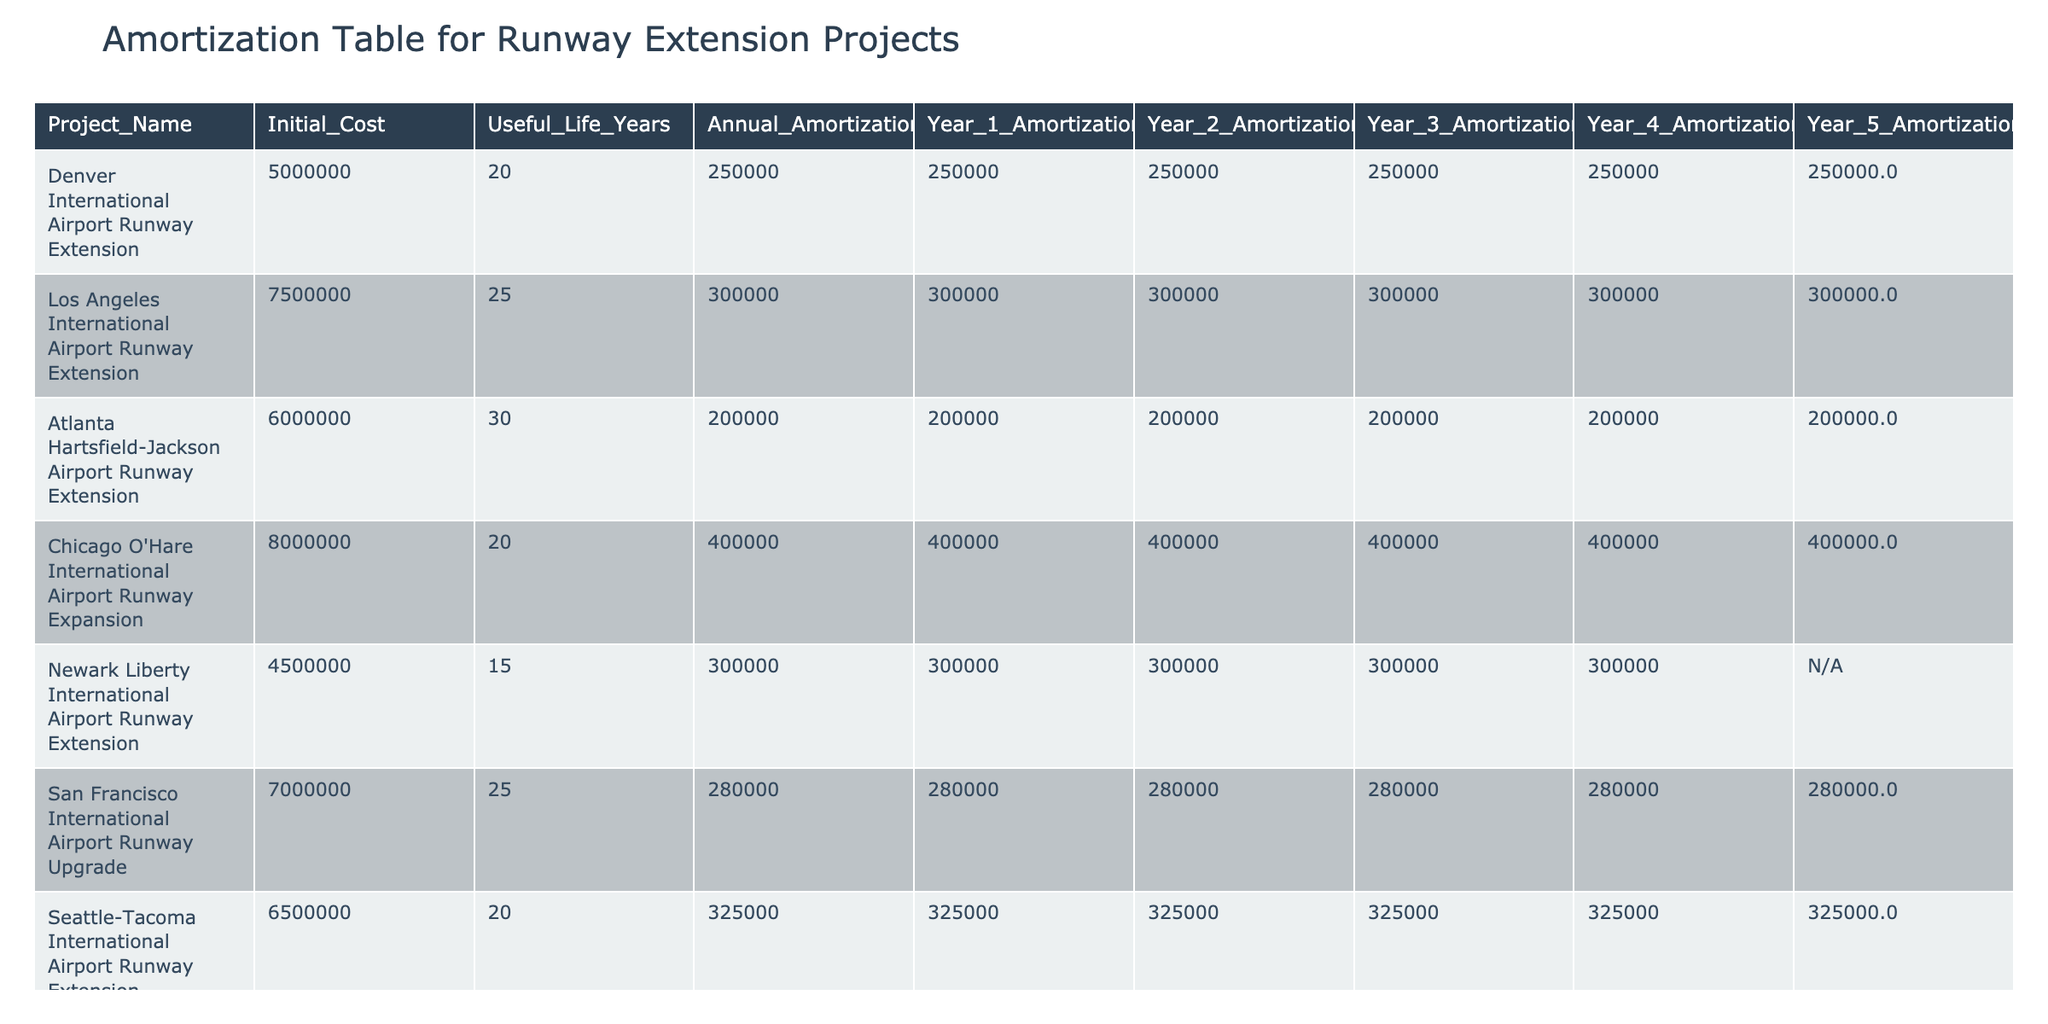What is the Initial Cost of the Los Angeles International Airport Runway Extension? The table shows that the Los Angeles International Airport Runway Extension has an Initial Cost listed in the relevant column, which is 7,500,000.
Answer: 7,500,000 How many years is the Useful Life of the Newark Liberty International Airport Runway Extension? The Useful Life Years for the Newark Liberty International Airport Runway Extension is provided in the table as 15 years.
Answer: 15 years What is the total Annual Amortization for all the projects combined? To find the total Annual Amortization, we add up the Annual Amortization values: 250000 + 300000 + 200000 + 400000 + 300000 + 280000 + 325000 + 183333 = 1,938,333.
Answer: 1,938,333 Is the Year 5 Amortization expense for the Miami International Airport Runway Expansion listed in the table? The table indicates that the Year 5 Amortization for the Miami International Airport Runway Expansion is marked as N/A, which means it is not available.
Answer: No Which project has the highest Annual Amortization expense? By reviewing the Annual Amortization values in the table, we find that the Chicago O'Hare International Airport Runway Expansion has the highest Annual Amortization at 400,000.
Answer: Chicago O'Hare International Airport Runway Expansion What is the average Initial Cost of all the runway extension projects listed? To calculate the average Initial Cost, add the Initial Costs (5,000,000 + 7,500,000 + 6,000,000 + 8,000,000 + 4,500,000 + 7,000,000 + 6,500,000 + 5,500,000) = 50,000,000, then divide by the number of projects (8) which is 50,000,000 / 8 = 6,250,000.
Answer: 6,250,000 What percentage of the total Annual Amortization does the Atlanta Hartsfield-Jackson Airport Runway Extension represent? The Annual Amortization for the Atlanta Hartsfield-Jackson Airport is 200,000. To find the percentage of the total, divide 200,000 by 1,938,333 (total Annual Amortization): (200,000 / 1,938,333) * 100 ≈ 10.32%.
Answer: 10.32% What is the useful life, in years, of the runway extension project with the lowest Initial Cost? The Newark Liberty International Airport Runway Extension has the lowest Initial Cost at 4,500,000, which has a Useful Life of 15 years as shown in the table.
Answer: 15 years Which project had the same Annual Amortization as the San Francisco International Airport Runway Upgrade? The Annual Amortization for the San Francisco International Airport Runway Upgrade is 280,000. By checking the table, we see that the project with the same Annual Amortization is the Denver International Airport Runway Extension due to its matching value.
Answer: Denver International Airport Runway Extension 